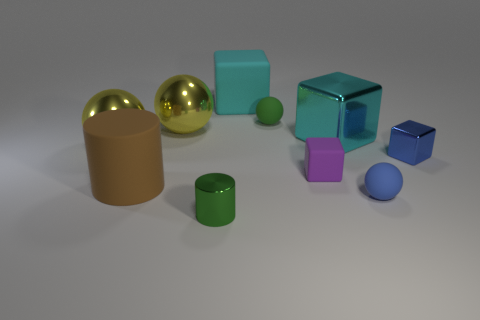Is the shape of the big object that is right of the cyan matte object the same as the green object behind the large brown rubber cylinder?
Your response must be concise. No. How many things are big rubber objects left of the cyan rubber cube or small green objects that are right of the tiny green metal object?
Offer a terse response. 2. What number of other things are there of the same material as the brown object
Offer a very short reply. 4. Are the tiny object that is behind the tiny blue block and the green cylinder made of the same material?
Make the answer very short. No. Are there more big cyan metal things in front of the blue cube than small rubber things on the right side of the purple block?
Your response must be concise. No. What number of things are balls in front of the green rubber ball or large cyan matte objects?
Provide a short and direct response. 4. There is a blue object that is the same material as the green cylinder; what is its shape?
Your response must be concise. Cube. Is there any other thing that is the same shape as the brown rubber object?
Your response must be concise. Yes. What color is the shiny object that is right of the metal cylinder and on the left side of the small shiny block?
Keep it short and to the point. Cyan. How many cubes are either green objects or large metallic objects?
Your answer should be compact. 1. 